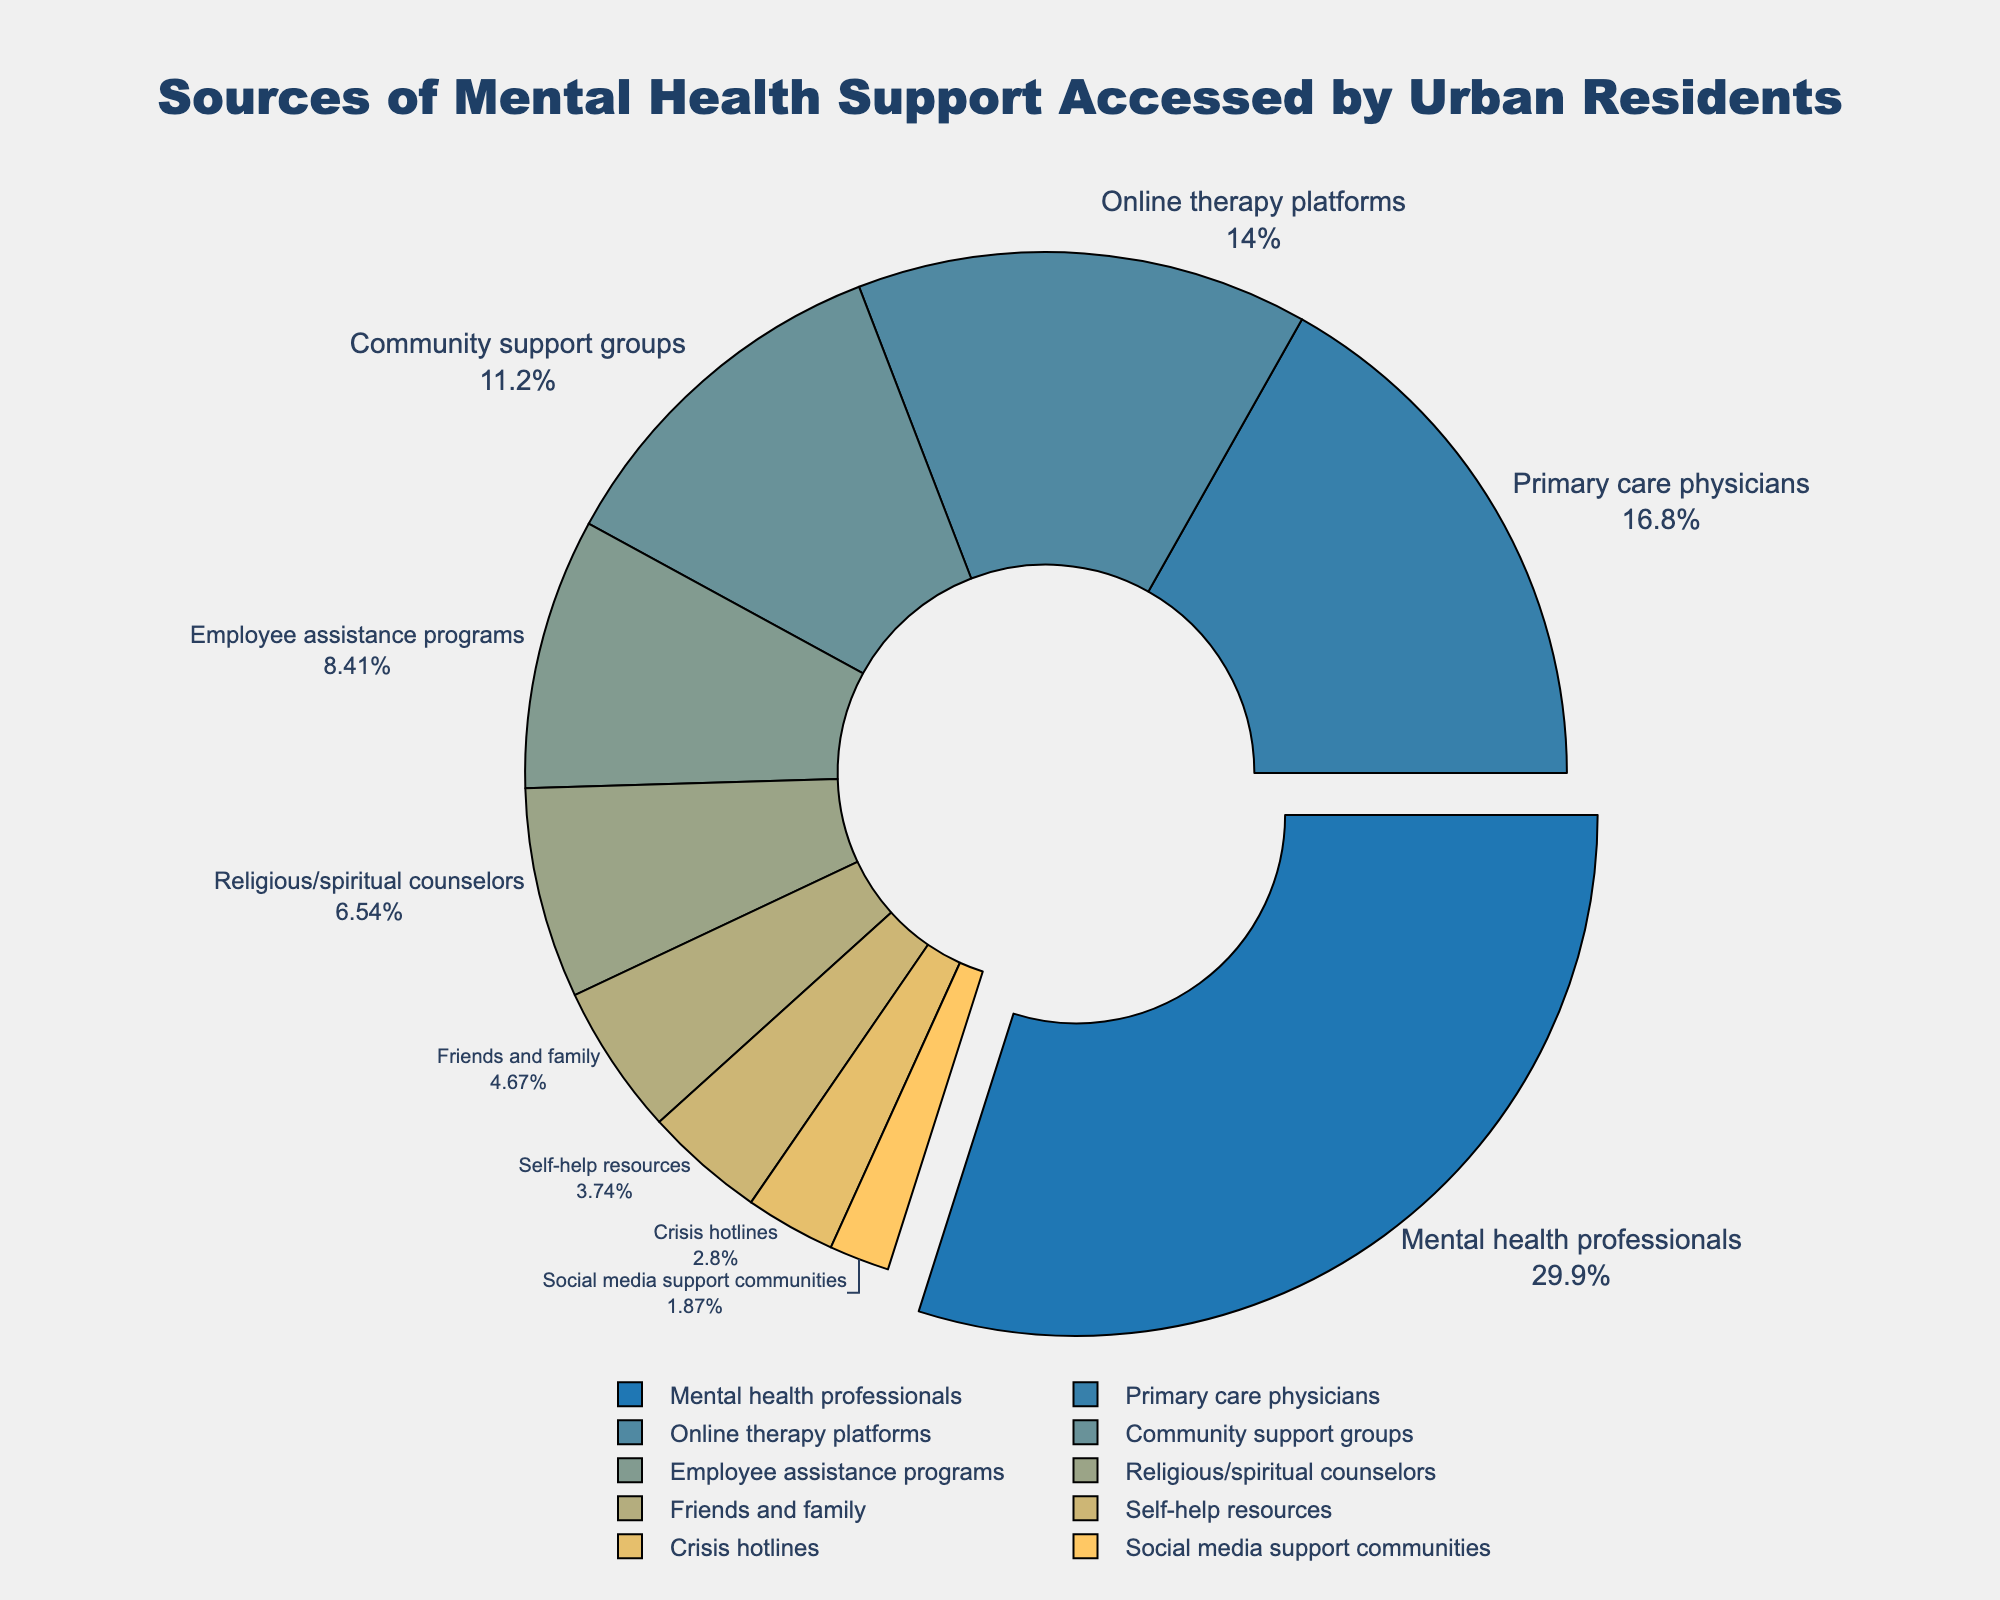What's the largest source of mental health support accessed by urban residents? The largest section of the pie chart represents "Mental health professionals" with 32% of the total.
Answer: Mental health professionals Which source of support is accessed more, online therapy platforms or employee assistance programs? The pie chart shows that "Online therapy platforms" have a larger percentage (15%) compared to "Employee assistance programs" (9%).
Answer: Online therapy platforms What is the combined percentage of urban residents accessing support from friends and family, and crisis hotlines? The percentage for "Friends and family" is 5%, and for "Crisis hotlines" it is 3%. Adding these together gives us 5% + 3% = 8%.
Answer: 8% Which three sources of support have the smallest percentages? The three smallest sections on the pie chart are "Crisis hotlines" (3%), "Social media support communities" (2%), and "Self-help resources" (4%).
Answer: Crisis hotlines, Social media support communities, Self-help resources How much more (%) do urban residents access mental health professionals compared to religious/spiritual counselors? The percentage accessing "Mental health professionals" is 32%, while for "Religious/spiritual counselors" it is 7%. The difference is 32% - 7% = 25%.
Answer: 25% Is the percentage of urban residents who access primary care physicians for mental health support higher or lower than those accessing community support groups? The pie chart shows that "Primary care physicians" are accessed by 18%, which is higher than "Community support groups" at 12%.
Answer: Higher What is the total percentage of urban residents accessing either online therapy platforms or community support groups? The percentage for "Online therapy platforms" is 15%, and for "Community support groups" it is 12%. Adding these together gives us 15% + 12% = 27%.
Answer: 27% Which source of mental health support is highlighted (pulled out) in the pie chart? The pie chart visually emphasizes "Mental health professionals" by pulling it out from the rest of the sections.
Answer: Mental health professionals How many sources of support have percentages under 10%? The sources with percentages under 10% are "Employee assistance programs" (9%), "Religious/spiritual counselors" (7%), "Friends and family" (5%), "Self-help resources" (4%), "Crisis hotlines" (3%), and "Social media support communities" (2%). There are 6 sources in total.
Answer: 6 What's the collective percentage of support accessed from sources related to professional services (mental health professionals, primary care physicians, employee assistance programs)? The percentages are "Mental health professionals" (32%), "Primary care physicians" (18%), and "Employee assistance programs" (9%). Adding these together gives us 32% + 18% + 9% = 59%.
Answer: 59% 